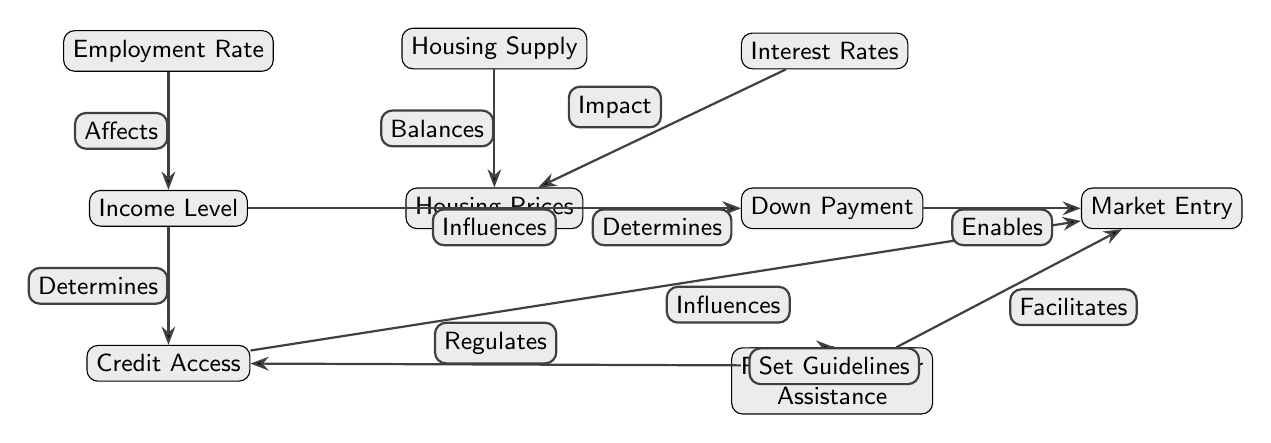What node directly influences Down Payment? The diagram shows an edge from Income Level to Down Payment, labeled "Influences." This indicates that Income Level directly affects the Down Payment.
Answer: Income Level How many nodes are in the diagram? By counting the distinct nodes listed, we find there are 10 nodes in total, including Income Level, Housing Prices, Employment Rate, Credit Access, Interest Rates, Federal Policies, Down Payment, Housing Supply, First-Time Buyer Assistance, and Market Entry.
Answer: 10 Which node does Housing Prices directly determine? The diagram indicates that Housing Prices has a direct edge leading to Down Payment labeled "Determines," meaning Housing Prices influences Down Payment.
Answer: Down Payment What two factors affect Income Level? The diagram shows one edge coming from Employment Rate labeled "Affects" and another from Credit Access labeled "Determines." Both of these nodes influence the Income Level collectively.
Answer: Employment Rate and Credit Access What facilitates Market Entry? The diagram highlights that First-Time Buyer Assistance has a direct edge towards Market Entry, labeled "Facilitates." Additionally, Down Payment and Credit Access also influence Market Entry.
Answer: First-Time Buyer Assistance What regulates credit access? In the diagram, Federal Policies is linked to Credit Access with the label "Regulates," indicating that Federal Policies have control over the terms of Credit Access.
Answer: Federal Policies Which factors impact Housing Prices? The diagram identifies Interest Rates and Housing Supply as two nodes with arrows pointing towards Housing Prices, hence these factors directly impact Housing Prices.
Answer: Interest Rates and Housing Supply Which node balances Housing Supply? The diagram shows an edge leading from Housing Supply to Housing Prices, with the label "Balances." This means that the node Housing Supply plays a role in balancing the related Housing Prices.
Answer: Housing Supply How is Down Payment influenced by Housing Prices? The diagram explicitly states that there is a connection labeled "Determines" from Housing Prices to Down Payment, indicating that the level of Housing Prices directly influences the Down Payment amount.
Answer: Determines 